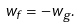Convert formula to latex. <formula><loc_0><loc_0><loc_500><loc_500>w _ { f } = - w _ { g } .</formula> 